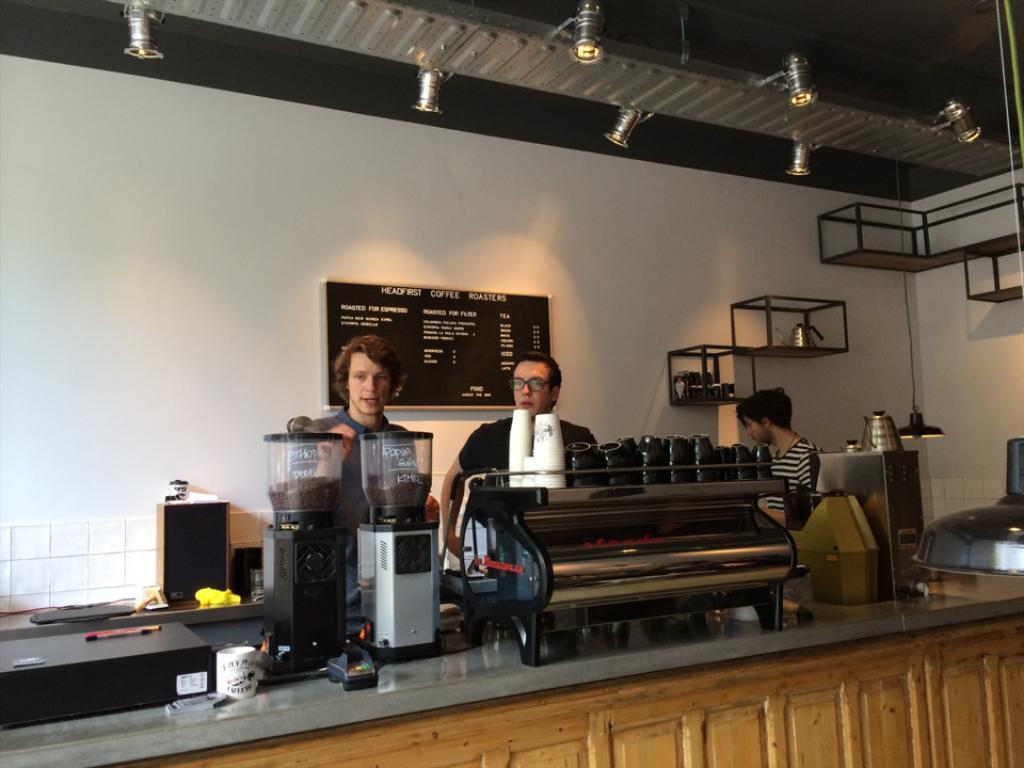<image>
Summarize the visual content of the image. Two men and a woman work behind the counter at Headfirst Coffee Roasters. 